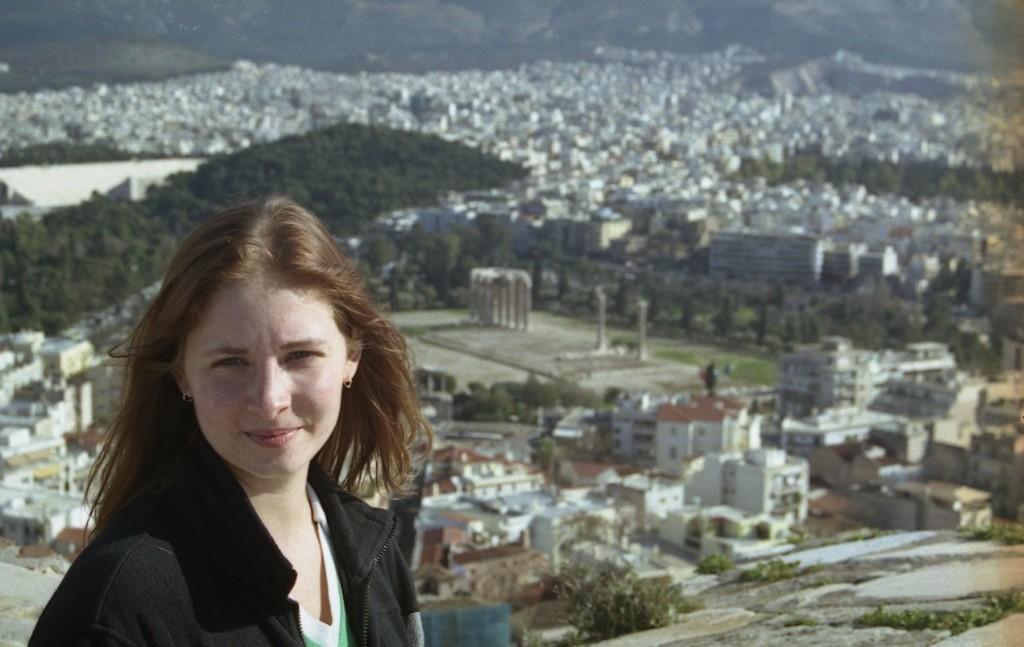What type of view is shown in the image? The image is an aerial view. Can you describe the lady visible in the image? There is a lady visible in the front of the image. What can be seen in the background of the image? There are buildings, trees, and hills visible in the background of the image. What else is present in the image? There are poles visible in the image. What type of pollution is visible in the image? There is no visible pollution in the image. What hobbies does the lady in the image enjoy? There is no information about the lady's hobbies in the image. 